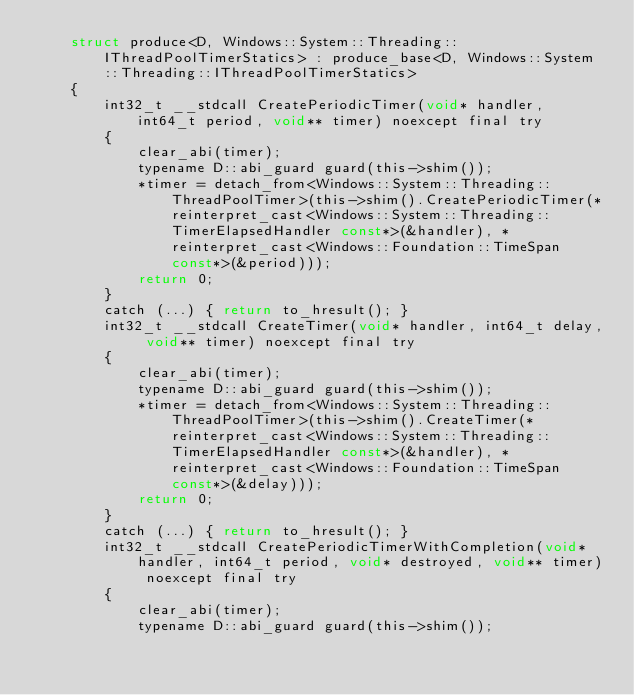<code> <loc_0><loc_0><loc_500><loc_500><_C_>    struct produce<D, Windows::System::Threading::IThreadPoolTimerStatics> : produce_base<D, Windows::System::Threading::IThreadPoolTimerStatics>
    {
        int32_t __stdcall CreatePeriodicTimer(void* handler, int64_t period, void** timer) noexcept final try
        {
            clear_abi(timer);
            typename D::abi_guard guard(this->shim());
            *timer = detach_from<Windows::System::Threading::ThreadPoolTimer>(this->shim().CreatePeriodicTimer(*reinterpret_cast<Windows::System::Threading::TimerElapsedHandler const*>(&handler), *reinterpret_cast<Windows::Foundation::TimeSpan const*>(&period)));
            return 0;
        }
        catch (...) { return to_hresult(); }
        int32_t __stdcall CreateTimer(void* handler, int64_t delay, void** timer) noexcept final try
        {
            clear_abi(timer);
            typename D::abi_guard guard(this->shim());
            *timer = detach_from<Windows::System::Threading::ThreadPoolTimer>(this->shim().CreateTimer(*reinterpret_cast<Windows::System::Threading::TimerElapsedHandler const*>(&handler), *reinterpret_cast<Windows::Foundation::TimeSpan const*>(&delay)));
            return 0;
        }
        catch (...) { return to_hresult(); }
        int32_t __stdcall CreatePeriodicTimerWithCompletion(void* handler, int64_t period, void* destroyed, void** timer) noexcept final try
        {
            clear_abi(timer);
            typename D::abi_guard guard(this->shim());</code> 